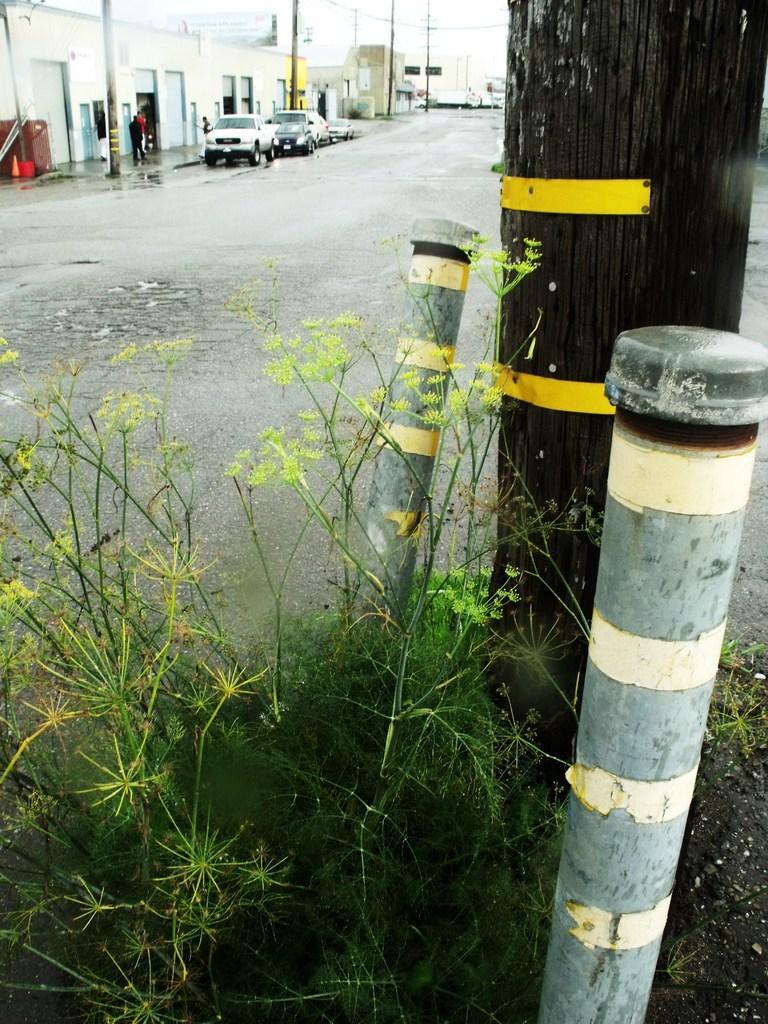Could you give a brief overview of what you see in this image? In this picture we can see some plants in the front, in the background there are cars, poles and buildings, we can also see three persons in the background, on the right side there is a tree bark. 